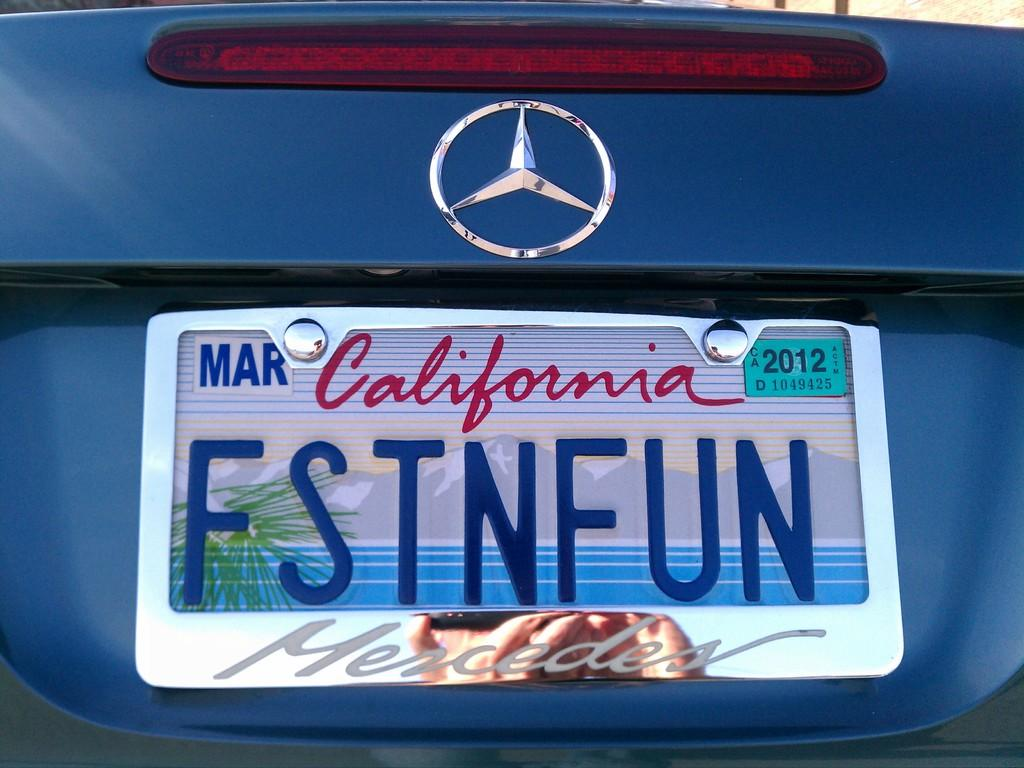Provide a one-sentence caption for the provided image. A personalized California liscense plate on a Mercedes. 